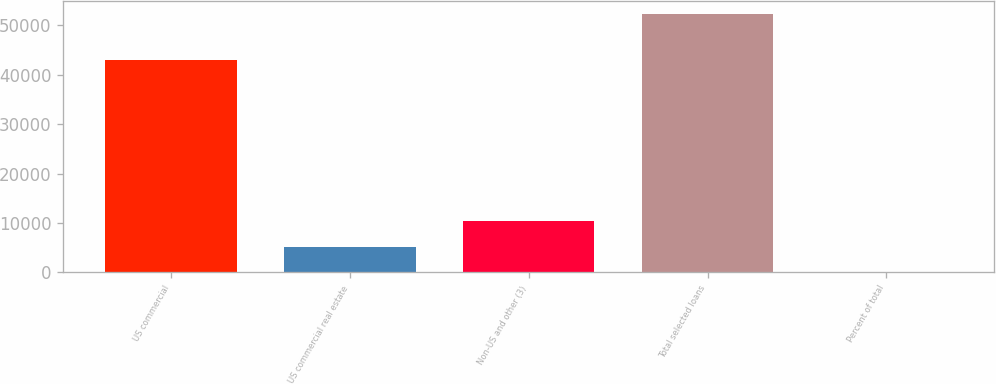<chart> <loc_0><loc_0><loc_500><loc_500><bar_chart><fcel>US commercial<fcel>US commercial real estate<fcel>Non-US and other (3)<fcel>Total selected loans<fcel>Percent of total<nl><fcel>42916<fcel>5244.2<fcel>10474.4<fcel>52316<fcel>14<nl></chart> 